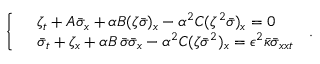Convert formula to latex. <formula><loc_0><loc_0><loc_500><loc_500>\left \{ \begin{array} { r l } & { \zeta _ { t } + A \bar { \sigma } _ { x } + \alpha B ( \zeta \bar { \sigma } ) _ { x } - \alpha ^ { 2 } C ( \zeta ^ { 2 } \bar { \sigma } ) _ { x } = 0 } \\ & { \bar { \sigma } _ { t } + \zeta _ { x } + \alpha B \, \bar { \sigma } \bar { \sigma } _ { x } - \alpha ^ { 2 } C ( \zeta \bar { \sigma } ^ { 2 } ) _ { x } = \epsilon ^ { 2 } \bar { \kappa } \bar { \sigma } _ { x x t } } \end{array} \, .</formula> 